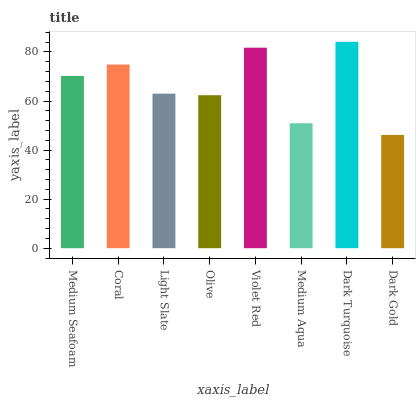Is Dark Gold the minimum?
Answer yes or no. Yes. Is Dark Turquoise the maximum?
Answer yes or no. Yes. Is Coral the minimum?
Answer yes or no. No. Is Coral the maximum?
Answer yes or no. No. Is Coral greater than Medium Seafoam?
Answer yes or no. Yes. Is Medium Seafoam less than Coral?
Answer yes or no. Yes. Is Medium Seafoam greater than Coral?
Answer yes or no. No. Is Coral less than Medium Seafoam?
Answer yes or no. No. Is Medium Seafoam the high median?
Answer yes or no. Yes. Is Light Slate the low median?
Answer yes or no. Yes. Is Medium Aqua the high median?
Answer yes or no. No. Is Violet Red the low median?
Answer yes or no. No. 